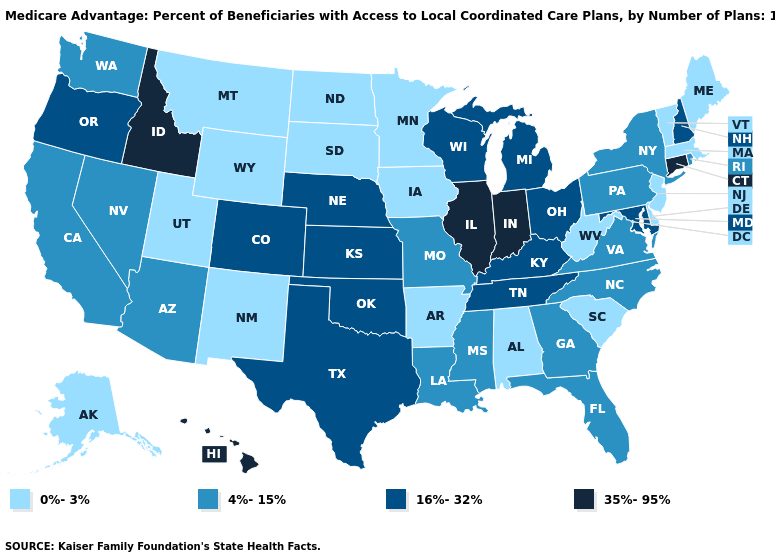Does California have the lowest value in the USA?
Answer briefly. No. Does the map have missing data?
Write a very short answer. No. Does Illinois have the highest value in the MidWest?
Give a very brief answer. Yes. How many symbols are there in the legend?
Be succinct. 4. Among the states that border Vermont , does Massachusetts have the highest value?
Keep it brief. No. Among the states that border North Carolina , which have the lowest value?
Quick response, please. South Carolina. Which states hav the highest value in the West?
Answer briefly. Hawaii, Idaho. Which states hav the highest value in the Northeast?
Answer briefly. Connecticut. Name the states that have a value in the range 0%-3%?
Give a very brief answer. Alaska, Alabama, Arkansas, Delaware, Iowa, Massachusetts, Maine, Minnesota, Montana, North Dakota, New Jersey, New Mexico, South Carolina, South Dakota, Utah, Vermont, West Virginia, Wyoming. What is the value of Kentucky?
Keep it brief. 16%-32%. Name the states that have a value in the range 35%-95%?
Short answer required. Connecticut, Hawaii, Idaho, Illinois, Indiana. What is the value of Colorado?
Quick response, please. 16%-32%. Does Georgia have the lowest value in the South?
Be succinct. No. Does the first symbol in the legend represent the smallest category?
Keep it brief. Yes. Among the states that border Wyoming , does Idaho have the highest value?
Be succinct. Yes. 